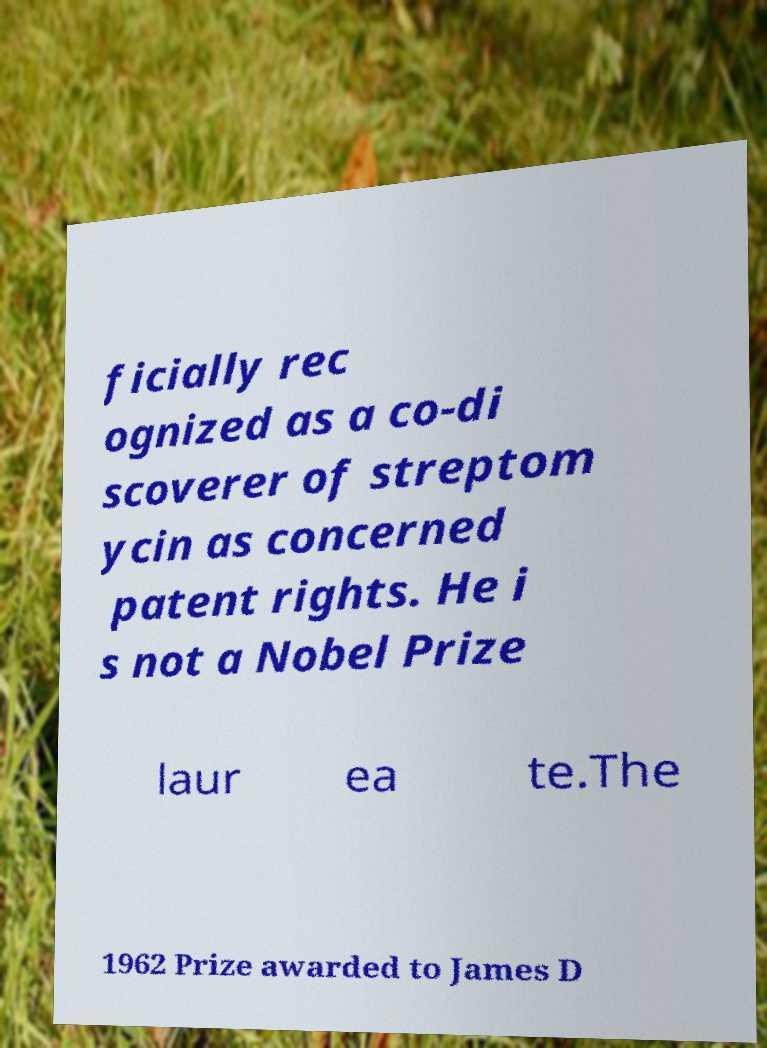Please identify and transcribe the text found in this image. ficially rec ognized as a co-di scoverer of streptom ycin as concerned patent rights. He i s not a Nobel Prize laur ea te.The 1962 Prize awarded to James D 